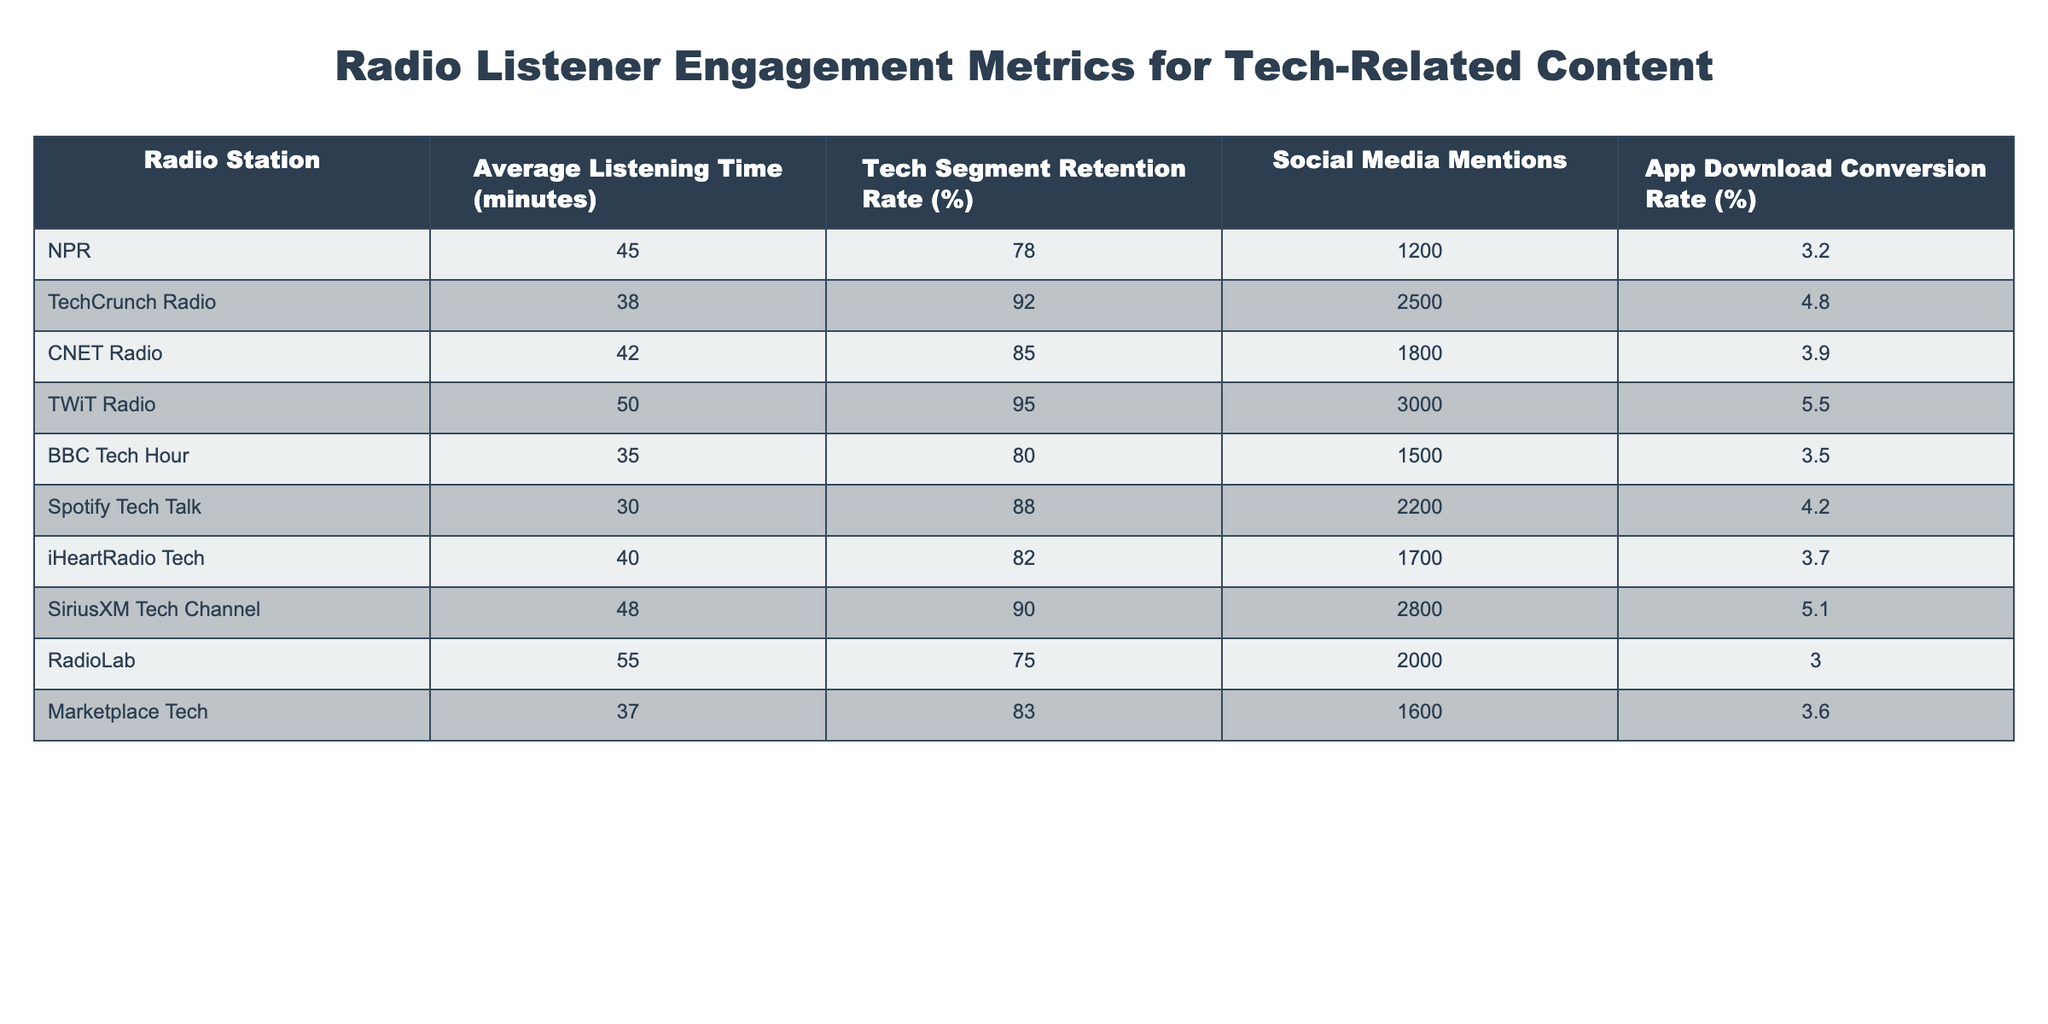What is the average listening time for TechCrunch Radio? The Average Listening Time for TechCrunch Radio is listed in the table as 38 minutes, which is a direct retrieval from the corresponding row.
Answer: 38 minutes Which radio station has the highest tech segment retention rate? The highest tech segment retention rate is 95%, which corresponds to TWiT Radio when looking through the retention rate column.
Answer: TWiT Radio How many social media mentions does SiriusXM Tech Channel have? The social media mentions for SiriusXM Tech Channel is specifically provided in the table as 2800, taken from the relevant row.
Answer: 2800 What is the average app download conversion rate for all the radio stations listed? To calculate the average conversion rate, sum all the rates: (3.2 + 4.8 + 3.9 + 5.5 + 3.5 + 4.2 + 3.7 + 5.1 + 3.0 + 3.6) = 43.5, then divide by the number of stations (10) to get 43.5/10 = 4.35.
Answer: 4.35% Which station has the lowest average listening time? The lowest average listening time in the table is for Spotify Tech Talk, which shows 30 minutes, requiring a comparison across the entire listening time column to confirm.
Answer: Spotify Tech Talk What is the combined social media mentions for NPR and CNET Radio? The social media mentions for NPR is 1200 and for CNET Radio is 1800; adding these values gives 1200 + 1800 = 3000 as the combined total.
Answer: 3000 Is the tech segment retention rate for RadioLab greater than 80%? The tech segment retention rate for RadioLab is listed as 75%, so we check if 75% is greater than 80%, which it is not, confirming the answer is false.
Answer: No Which radio station has an app download conversion rate above 5%? The app download conversion rates listed are 5.5% for TWiT Radio and 5.1% for SiriusXM Tech Channel; therefore, we identify TWiT Radio as the only one above 5%.
Answer: TWiT Radio What is the difference between the highest and lowest average listening times? The highest average listening time is 55 minutes (RadioLab) and the lowest is 30 minutes (Spotify Tech Talk); the difference is 55 - 30 = 25 minutes.
Answer: 25 minutes How does the tech segment retention rate of CNET Radio compare to the average of all stations? The average retention rate is calculated to be 83.5% (from all stations), and CNET Radio's rate is 85%, which is higher than the average. Hence, CNET has a better retention rate.
Answer: Higher than average 